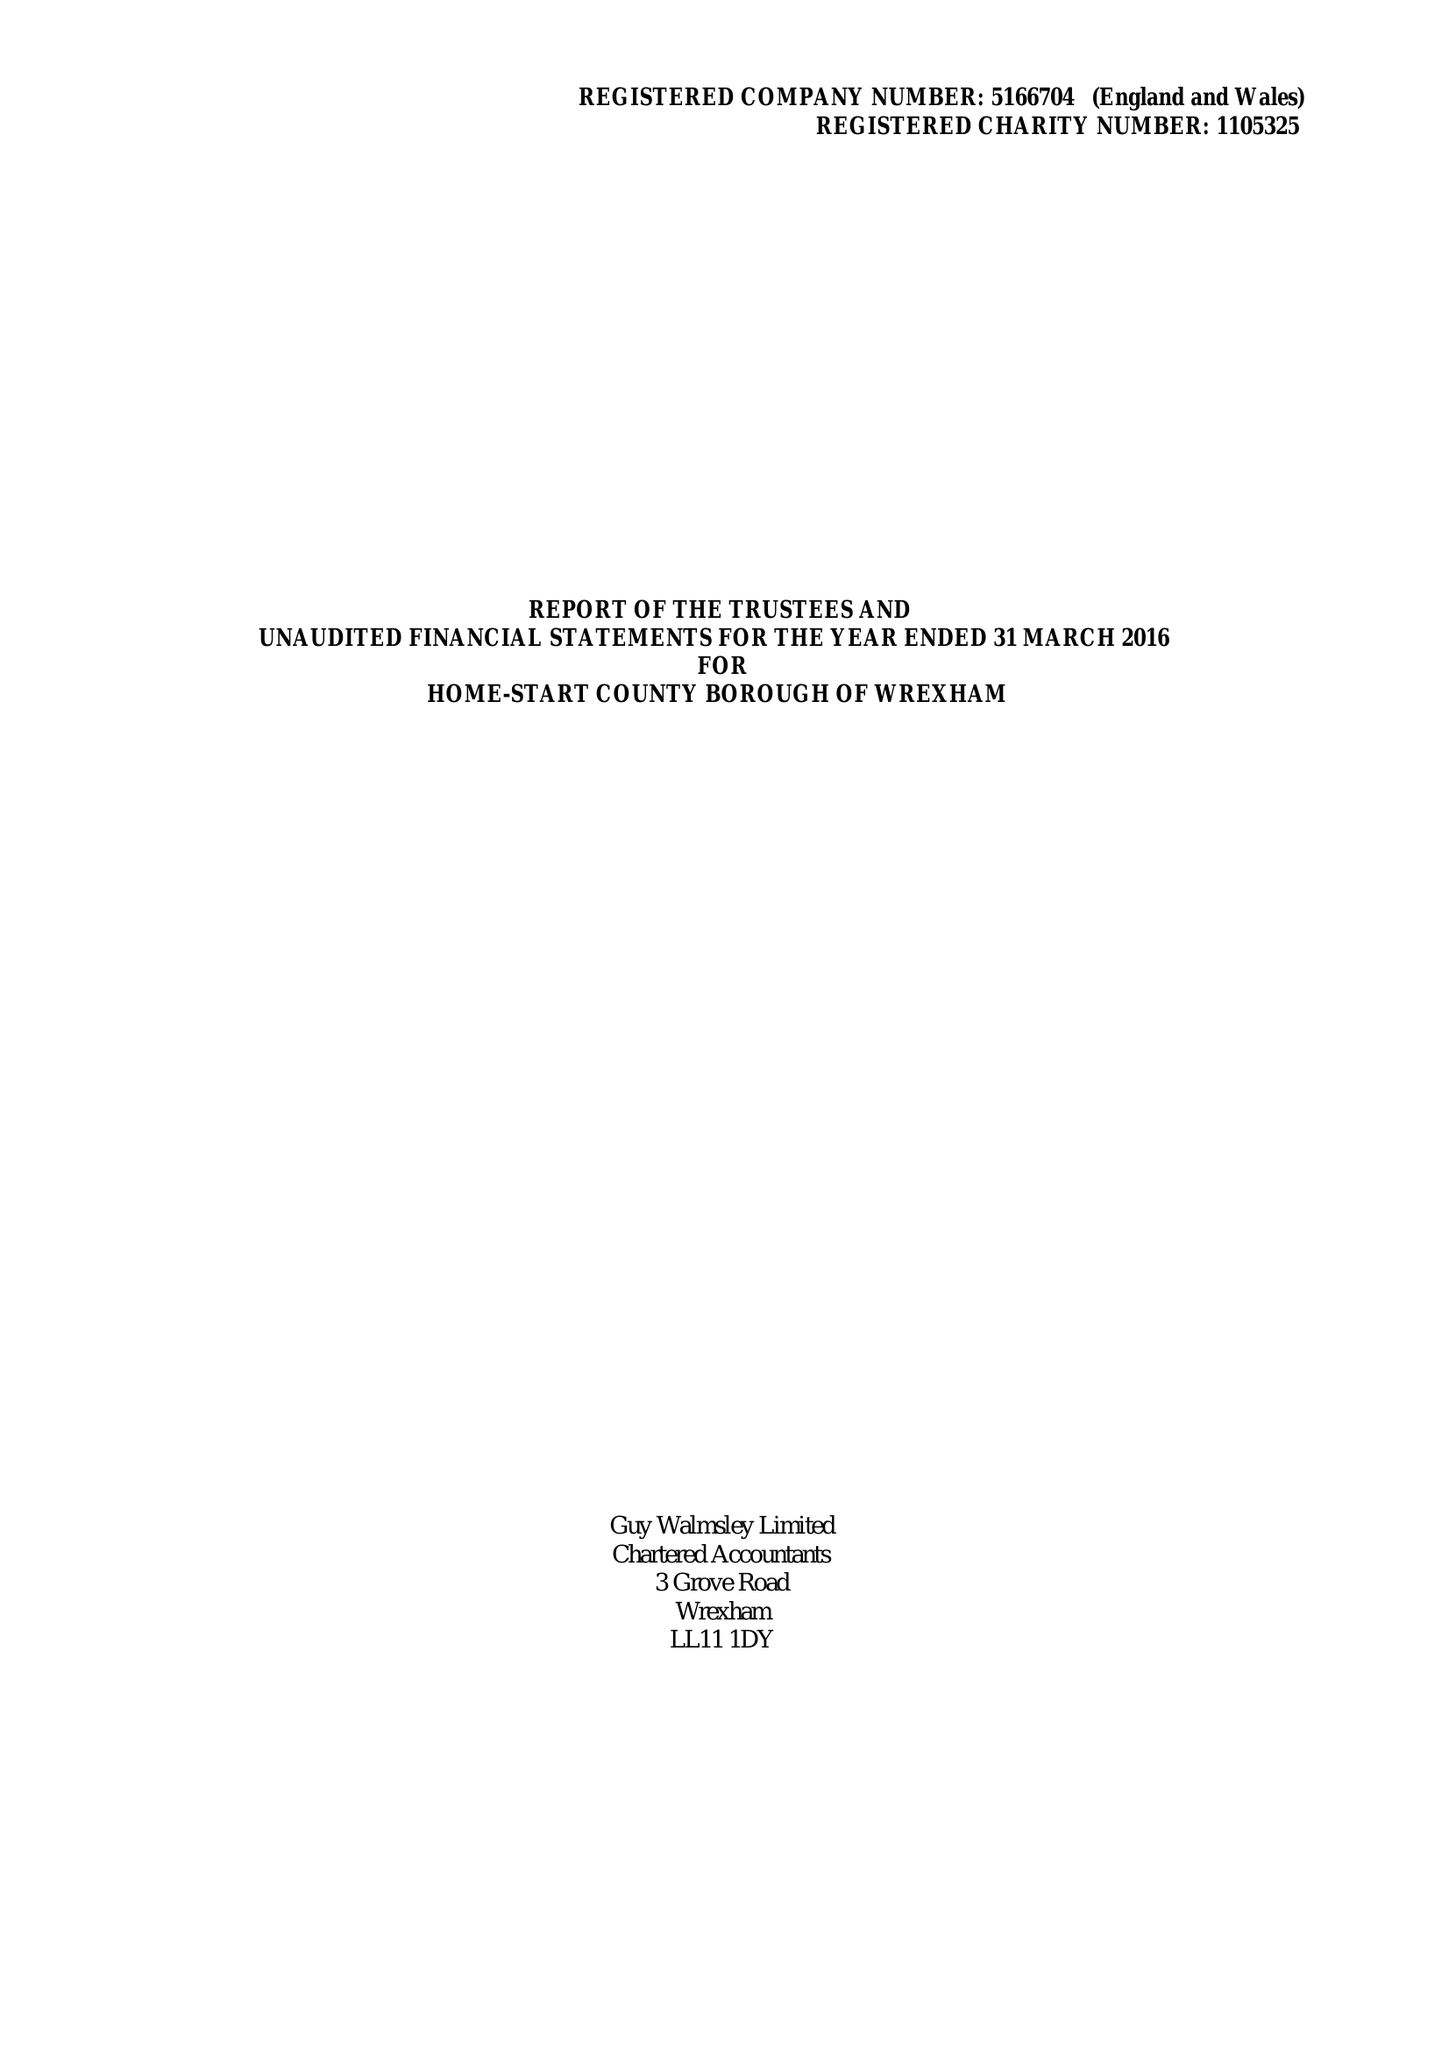What is the value for the address__postcode?
Answer the question using a single word or phrase. LL11 2NU 